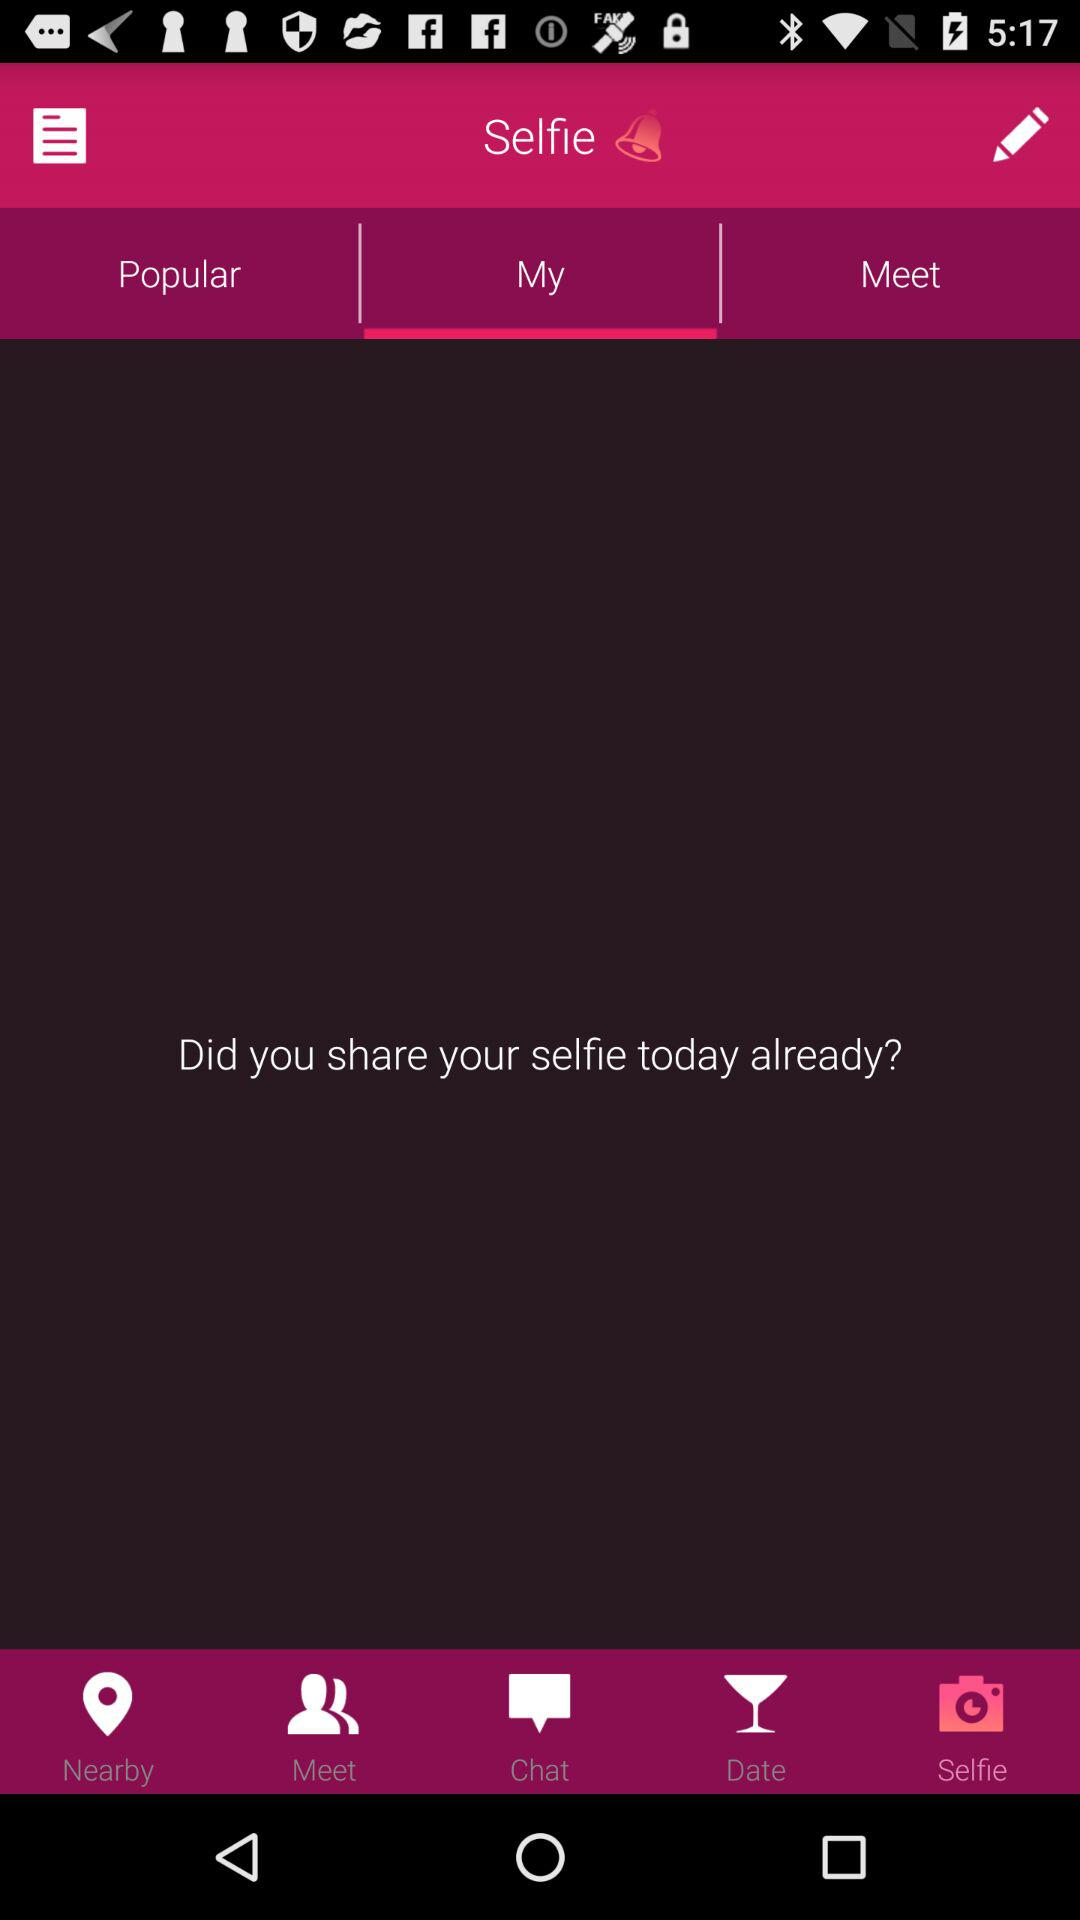What is the selected tab? The selected tab is "My". 